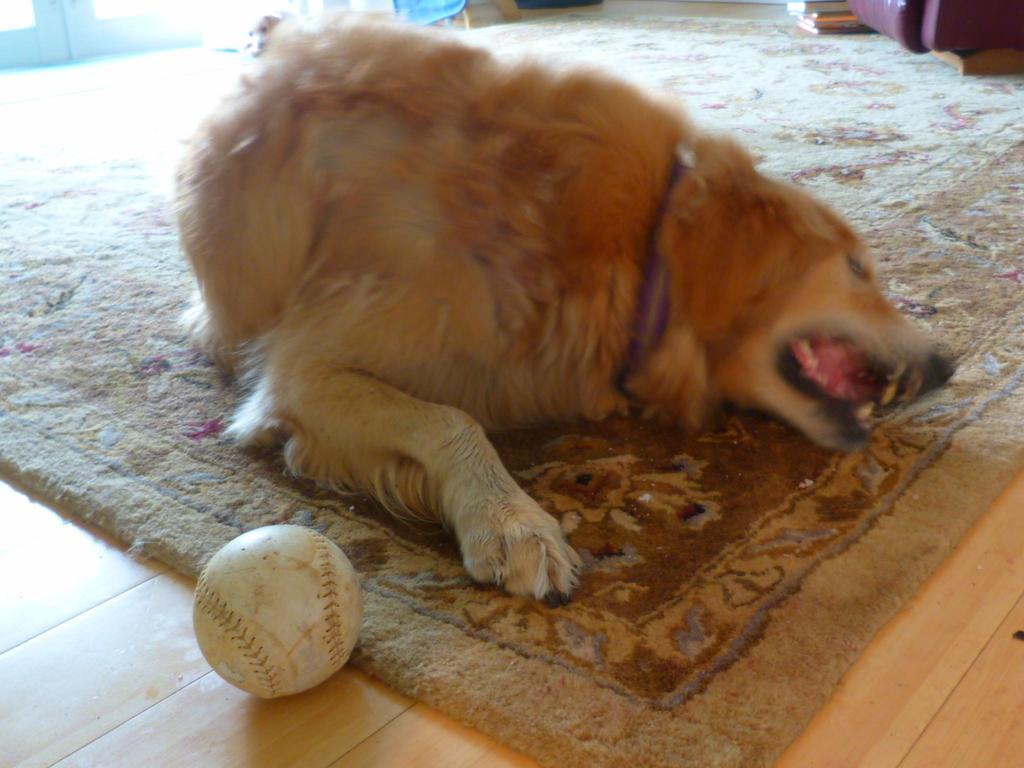Please provide a concise description of this image. In the picture I can see a dog on the carpet. I can see a ball on the floor on the bottom left side of the picture. I can see another dog on the top left side of the picture. 